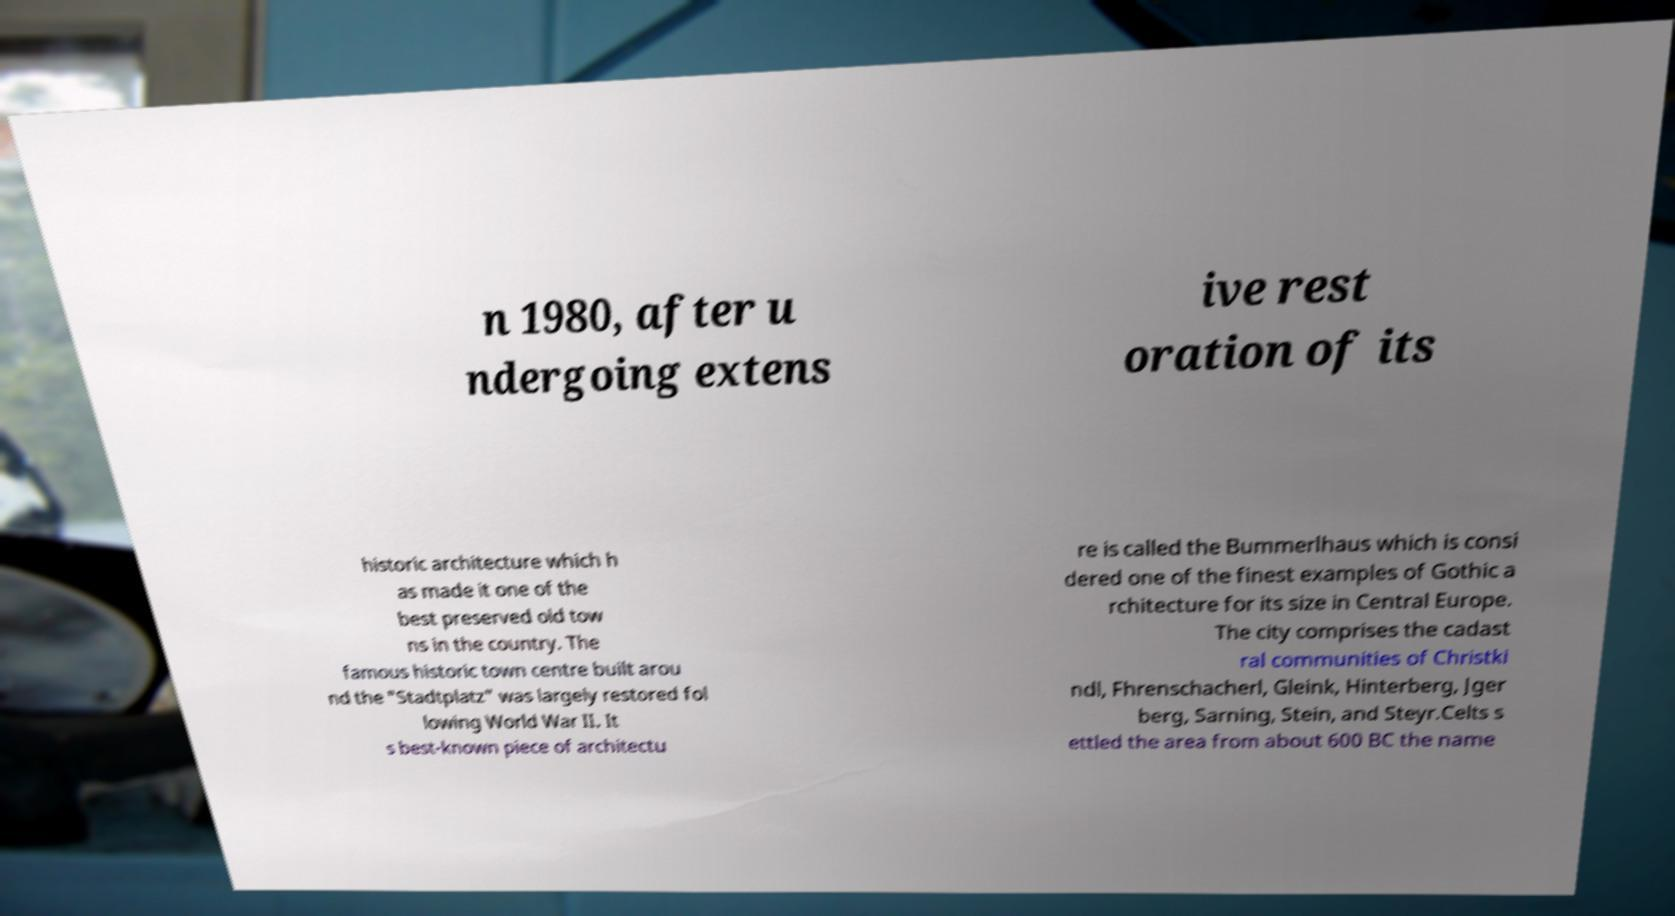Can you read and provide the text displayed in the image?This photo seems to have some interesting text. Can you extract and type it out for me? n 1980, after u ndergoing extens ive rest oration of its historic architecture which h as made it one of the best preserved old tow ns in the country. The famous historic town centre built arou nd the "Stadtplatz" was largely restored fol lowing World War II. It s best-known piece of architectu re is called the Bummerlhaus which is consi dered one of the finest examples of Gothic a rchitecture for its size in Central Europe. The city comprises the cadast ral communities of Christki ndl, Fhrenschacherl, Gleink, Hinterberg, Jger berg, Sarning, Stein, and Steyr.Celts s ettled the area from about 600 BC the name 